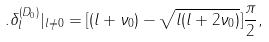<formula> <loc_0><loc_0><loc_500><loc_500>. \delta _ { l } ^ { ( D _ { 0 } ) } | _ { l \neq 0 } = [ ( l + \nu _ { 0 } ) - \sqrt { l ( l + 2 \nu _ { 0 } ) } ] \frac { \pi } { 2 } ,</formula> 